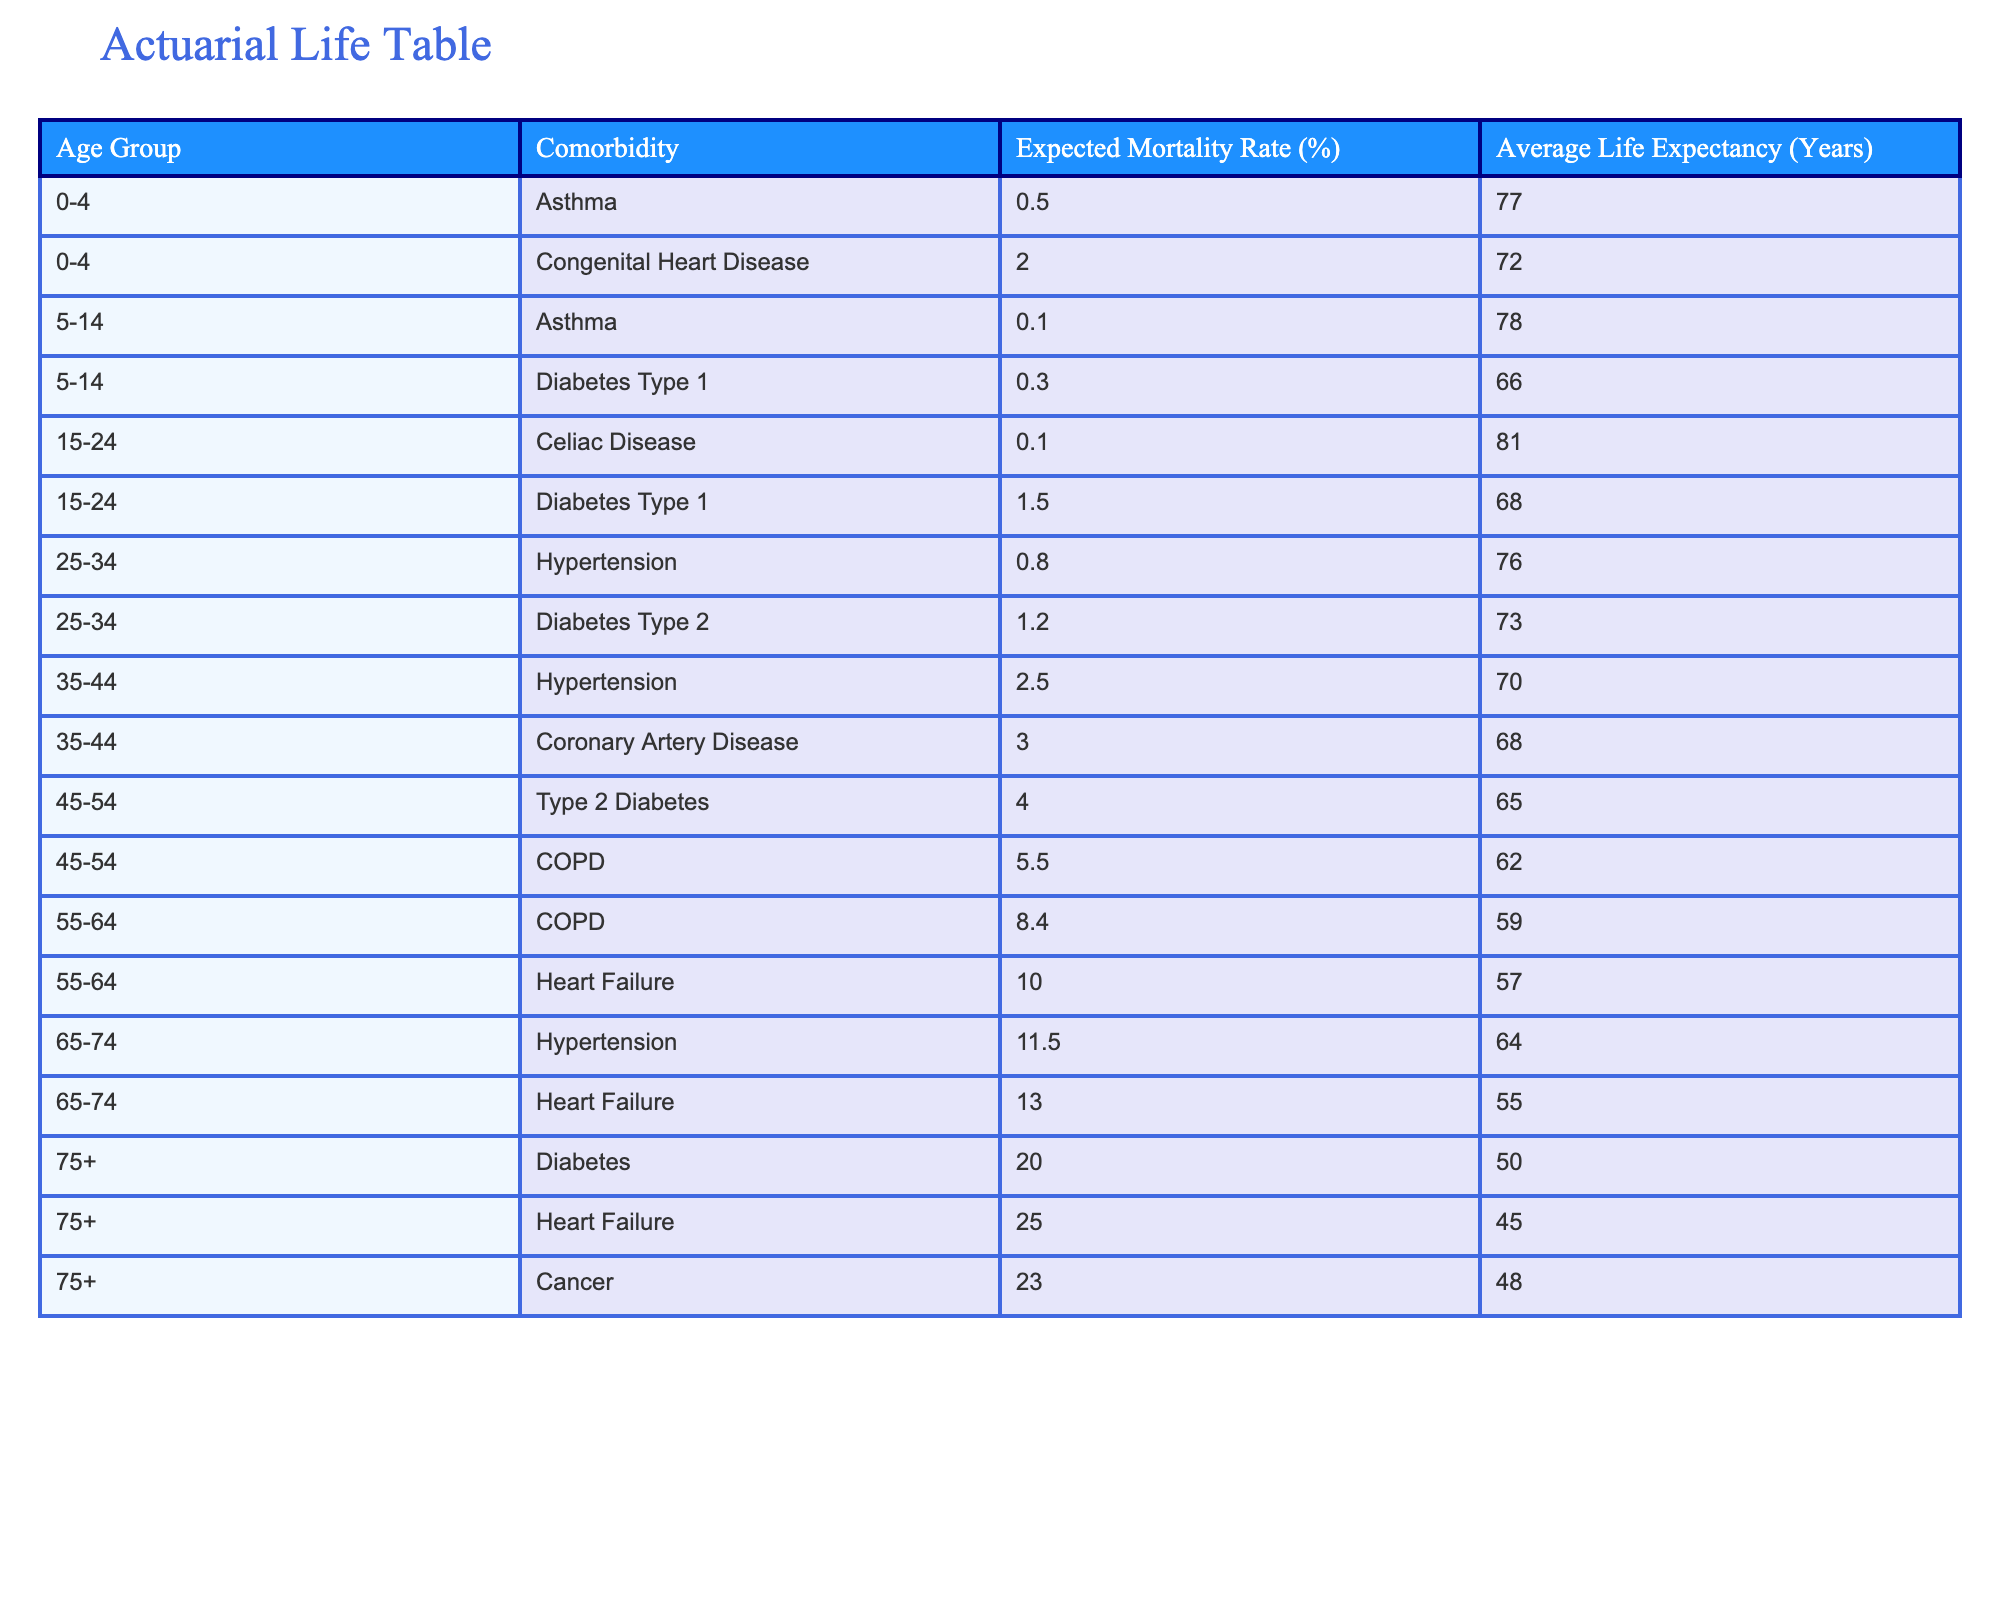What is the expected mortality rate for patients aged 65-74 with heart failure? Referring to the table, the expected mortality rate for the age group 65-74 with heart failure is 13.0%.
Answer: 13.0% Which age group has the highest average life expectancy? By examining the average life expectancy column, the age group 0-4 has the highest average life expectancy of 77 years.
Answer: 0-4 What is the difference in average life expectancy between patients with COPD aged 45-54 and those aged 55-64? For patients aged 45-54 with COPD, the average life expectancy is 62 years, and for those aged 55-64, it is 59 years. The difference in average life expectancy is 62 - 59 = 3 years.
Answer: 3 years Is the expected mortality rate for patients aged 75 and over with diabetes higher than that of those with cancer in the same age group? For patients aged 75 and over, the expected mortality rate for diabetes is 20.0%, while for cancer it is 23.0%. Since 20.0% < 23.0%, the statement is false.
Answer: No What is the total expected mortality rate for patients aged 75 and over, considering diabetes, heart failure, and cancer? The expected mortality rates for diabetes, heart failure, and cancer in the age group 75+ are 20.0%, 25.0%, and 23.0%, respectively. Summing these gives 20.0 + 25.0 + 23.0 = 68.0%.
Answer: 68.0% 